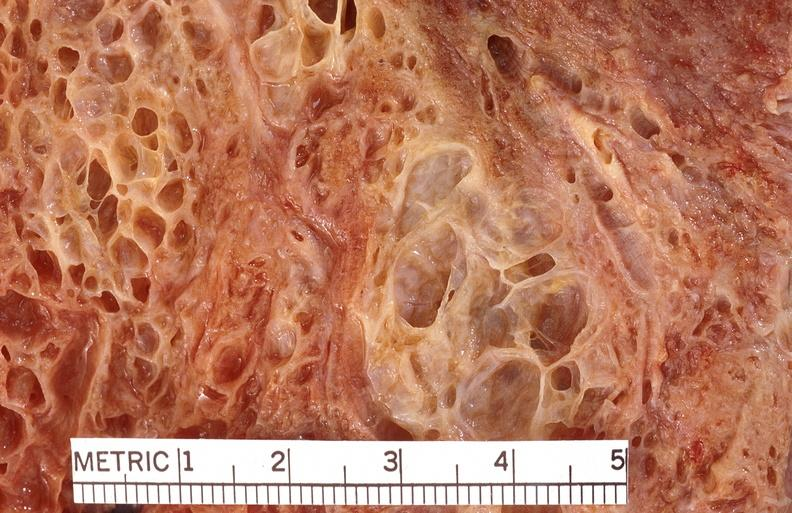s respiratory present?
Answer the question using a single word or phrase. Yes 